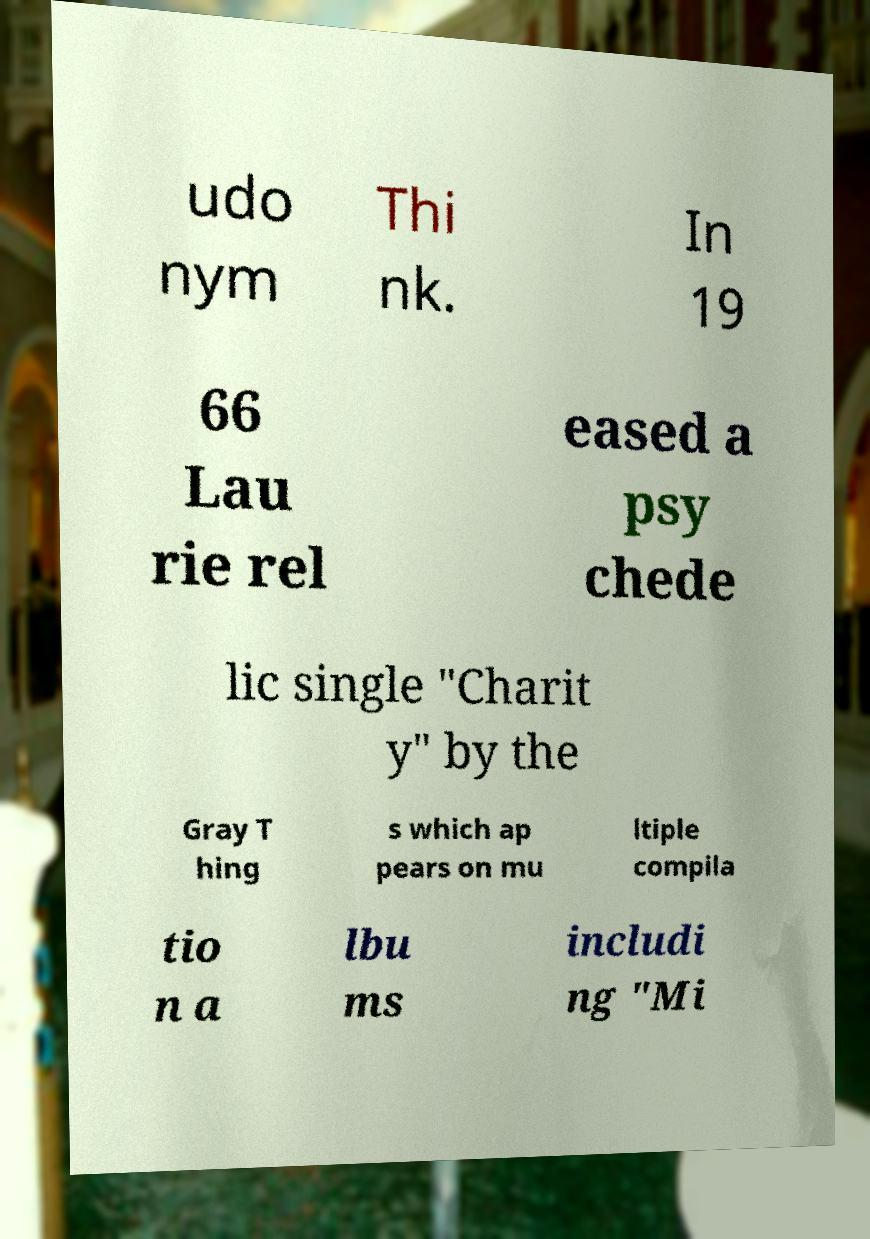Could you assist in decoding the text presented in this image and type it out clearly? udo nym Thi nk. In 19 66 Lau rie rel eased a psy chede lic single "Charit y" by the Gray T hing s which ap pears on mu ltiple compila tio n a lbu ms includi ng "Mi 